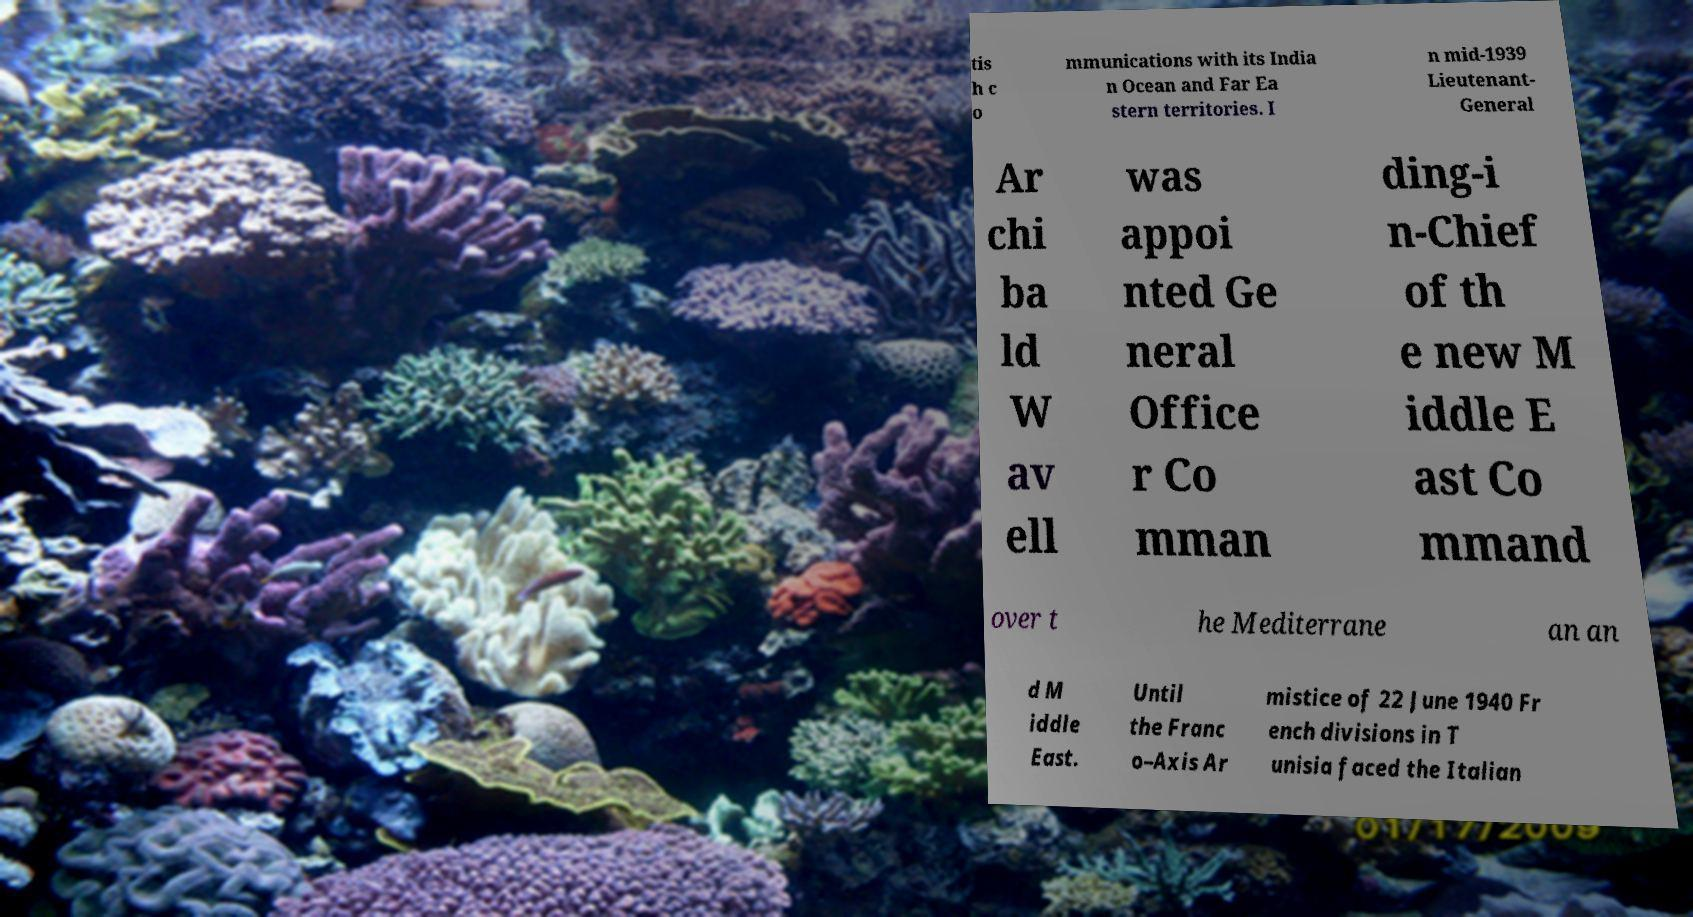For documentation purposes, I need the text within this image transcribed. Could you provide that? tis h c o mmunications with its India n Ocean and Far Ea stern territories. I n mid-1939 Lieutenant- General Ar chi ba ld W av ell was appoi nted Ge neral Office r Co mman ding-i n-Chief of th e new M iddle E ast Co mmand over t he Mediterrane an an d M iddle East. Until the Franc o–Axis Ar mistice of 22 June 1940 Fr ench divisions in T unisia faced the Italian 